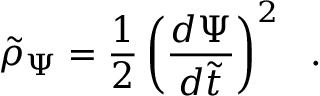<formula> <loc_0><loc_0><loc_500><loc_500>\tilde { \rho } _ { \Psi } = { \frac { 1 } { 2 } } \left ( { \frac { d \Psi } { d \tilde { t } } } \right ) ^ { 2 } \ \ .</formula> 